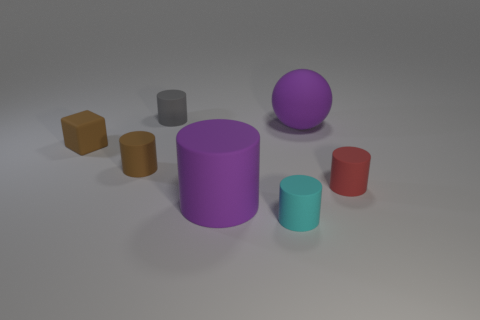Subtract all gray cylinders. How many cylinders are left? 4 Add 1 cyan metal cylinders. How many objects exist? 8 Subtract all purple cylinders. How many cylinders are left? 4 Subtract all blue cylinders. Subtract all cyan balls. How many cylinders are left? 5 Subtract all red rubber cylinders. Subtract all small cylinders. How many objects are left? 2 Add 5 small cyan matte objects. How many small cyan matte objects are left? 6 Add 1 small red metallic spheres. How many small red metallic spheres exist? 1 Subtract 0 blue cylinders. How many objects are left? 7 Subtract all cylinders. How many objects are left? 2 